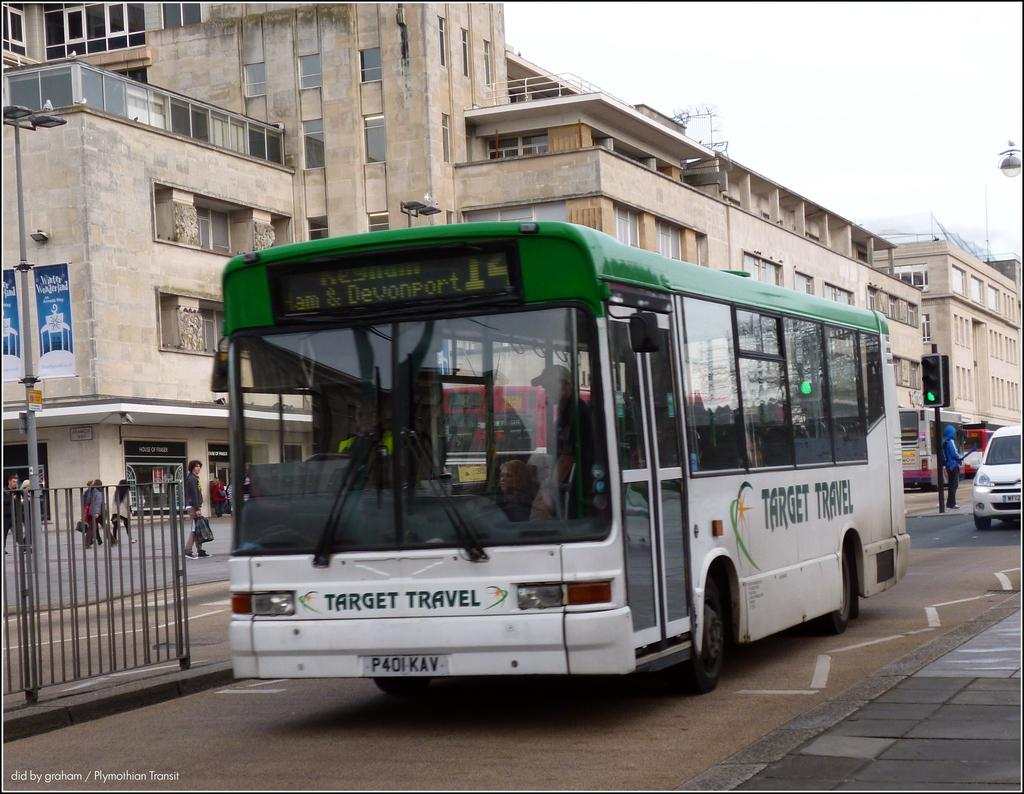<image>
Summarize the visual content of the image. A white and green bus has the Target Travel logo on the front. 